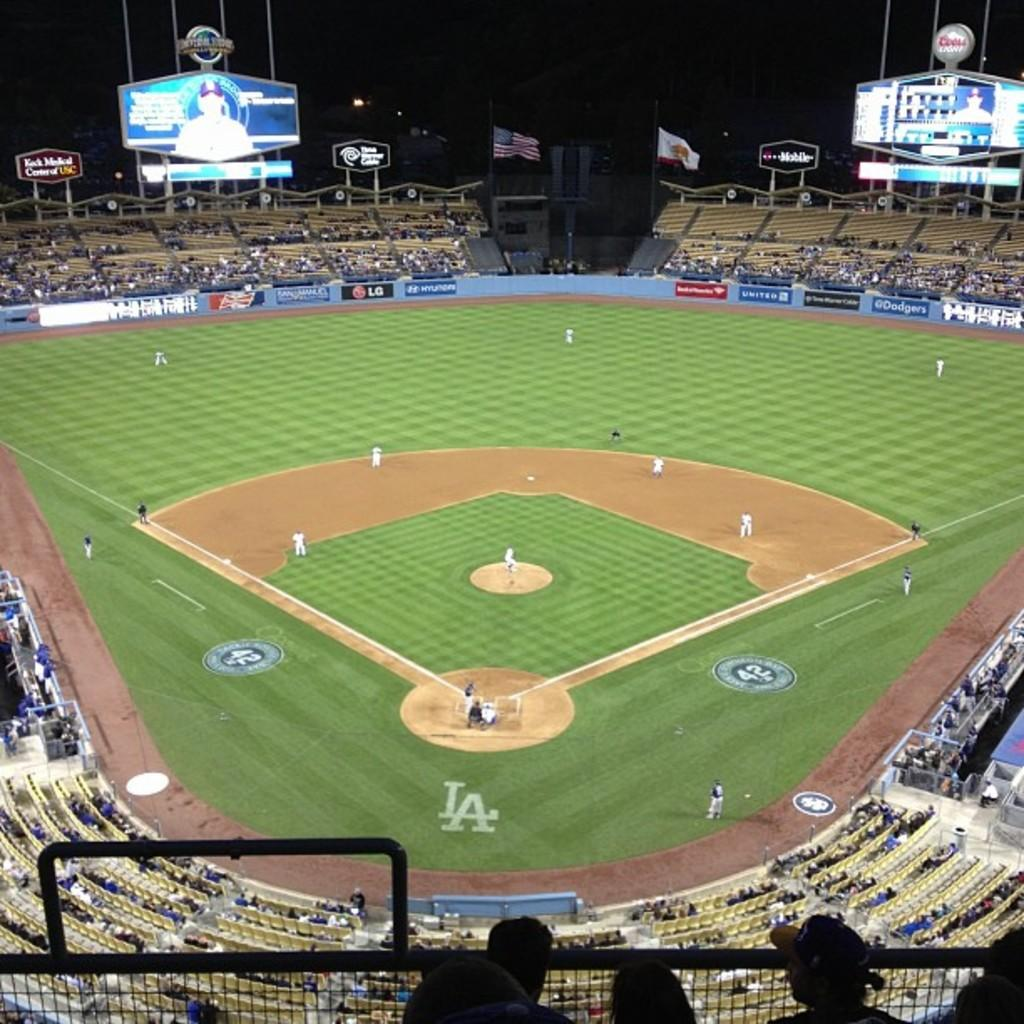<image>
Relay a brief, clear account of the picture shown. A baseball field with the letters LA on it and the number 42 on it. 